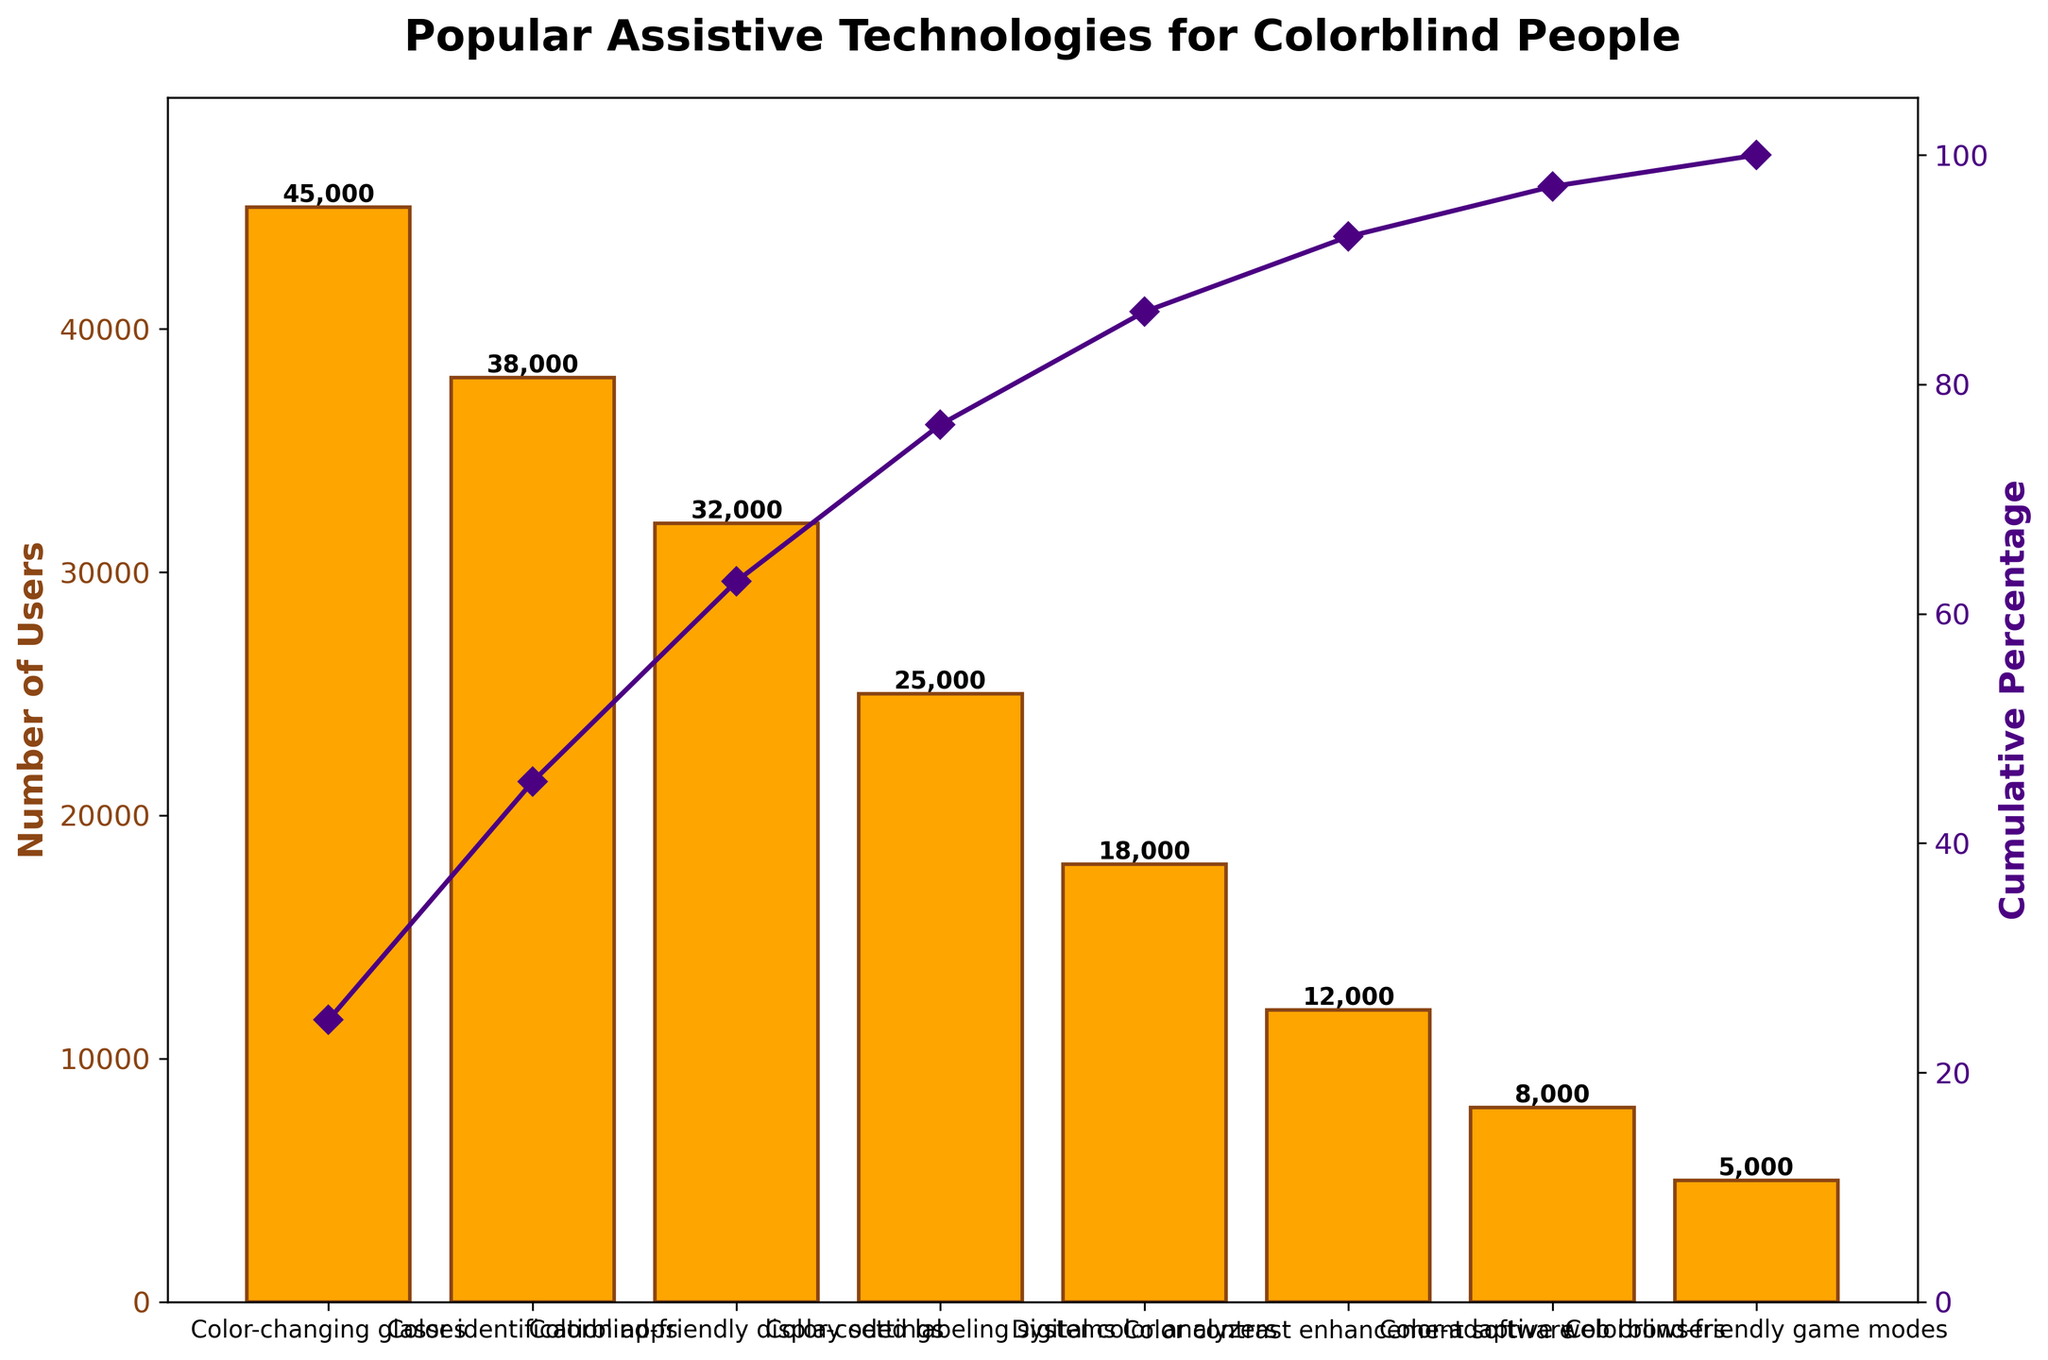What's the title of the chart? The title is at the top of the chart and it describes the main subject of the visualization.
Answer: Popular Assistive Technologies for Colorblind People What is the technology with the highest number of users? Look for the tallest bar in the chart. The corresponding category on the x-axis represents the technology with the highest usage.
Answer: Color-changing glasses Which technology has the lowest adoption rate? Identify the shortest bar in the chart, and read the technology name on the x-axis.
Answer: Colorblind-friendly game modes How many users utilize color identification apps? Find the bar labeled "Color identification apps" and check the value at its top or at the y-axis level.
Answer: 38,000 What is the cumulative percentage of users for the top two technologies? Add the cumulative percentages of the first two technologies as shown on the cumulative percentage line. The first is at around 34%, and the second at around 62%.
Answer: 96% Which three technologies, when combined, cover more than 80% of user adoption? Find the cumulative percentage values and determine when the sum surpasses 80%. The first three technologies (Color-changing glasses, Color identification apps, Colorblind-friendly display settings) show percentages summing up to around 84%.
Answer: Color-changing glasses, Color identification apps, Colorblind-friendly display settings What is the difference in user numbers between color-coded labeling systems and digital color analyzers? Read the values of users from the bars for both technologies and subtract one from the other. 25,000 - 18,000 = 7,000.
Answer: 7,000 What does the secondary y-axis represent? The label next to the right y-axis indicates what it measures.
Answer: Cumulative Percentage Which technology has a user count closest to the average number of users across all technologies? Sum all user counts and divide by the number of technologies to get the average. Look for the bar with a user count closest to this average. (sum = 182,000, average = 182,000/8 = 22,750). Digital color analyzers have 18,000 users, closest to this value.
Answer: Digital color analyzers By how much does the number of users for the least adopted technology differ from that of Colorblind-friendly display settings? Find the user count difference between Colorblind-friendly game modes (5,000) and Colorblind-friendly display settings (32,000). 32,000 - 5,000 = 27,000.
Answer: 27,000 